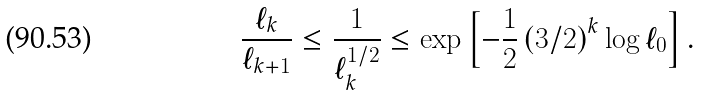<formula> <loc_0><loc_0><loc_500><loc_500>\frac { \ell _ { k } } { \ell _ { k + 1 } } \leq \frac { 1 } { \ell _ { k } ^ { 1 / 2 } } \leq \exp \left [ - \frac { 1 } { 2 } \left ( { 3 } / { 2 } \right ) ^ { k } \log \ell _ { 0 } \right ] .</formula> 